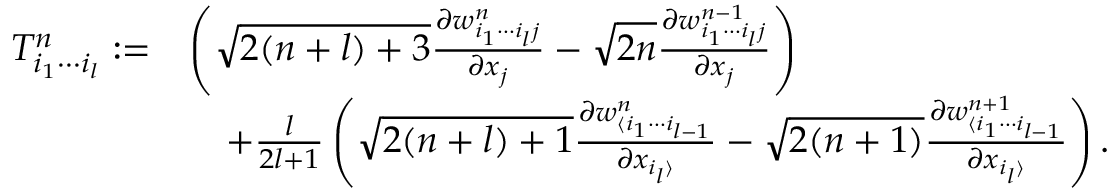Convert formula to latex. <formula><loc_0><loc_0><loc_500><loc_500>\begin{array} { r l } { T _ { i _ { 1 } \cdots i _ { l } } ^ { n } \colon = } & { \left ( \sqrt { 2 ( n + l ) + 3 } \frac { \partial w _ { i _ { 1 } \cdots i _ { l } j } ^ { n } } { \partial x _ { j } } - \sqrt { 2 n } \frac { \partial w _ { i _ { 1 } \cdots i _ { l } j } ^ { n - 1 } } { \partial x _ { j } } \right ) } \\ & { \quad + \frac { l } { 2 l + 1 } \left ( \sqrt { 2 ( n + l ) + 1 } \frac { \partial w _ { \langle i _ { 1 } \cdots i _ { l - 1 } } ^ { n } } { \partial x _ { i _ { l } \rangle } } - \sqrt { 2 ( n + 1 ) } \frac { \partial w _ { \langle i _ { 1 } \cdots i _ { l - 1 } } ^ { n + 1 } } { \partial x _ { i _ { l } \rangle } } \right ) . } \end{array}</formula> 